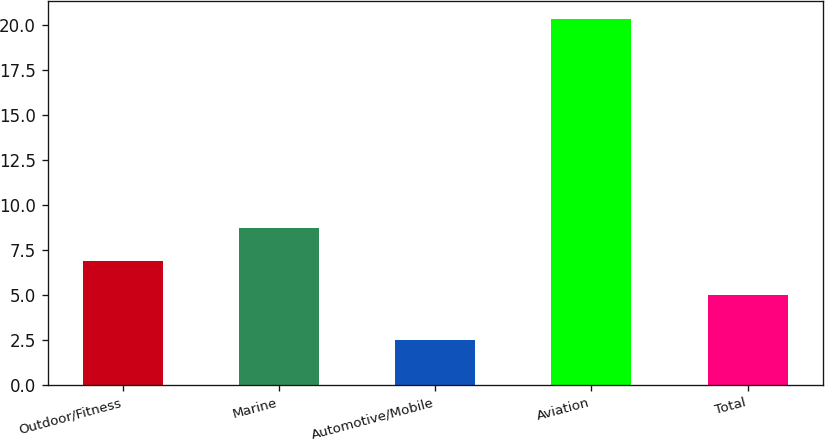<chart> <loc_0><loc_0><loc_500><loc_500><bar_chart><fcel>Outdoor/Fitness<fcel>Marine<fcel>Automotive/Mobile<fcel>Aviation<fcel>Total<nl><fcel>6.9<fcel>8.68<fcel>2.5<fcel>20.3<fcel>5<nl></chart> 